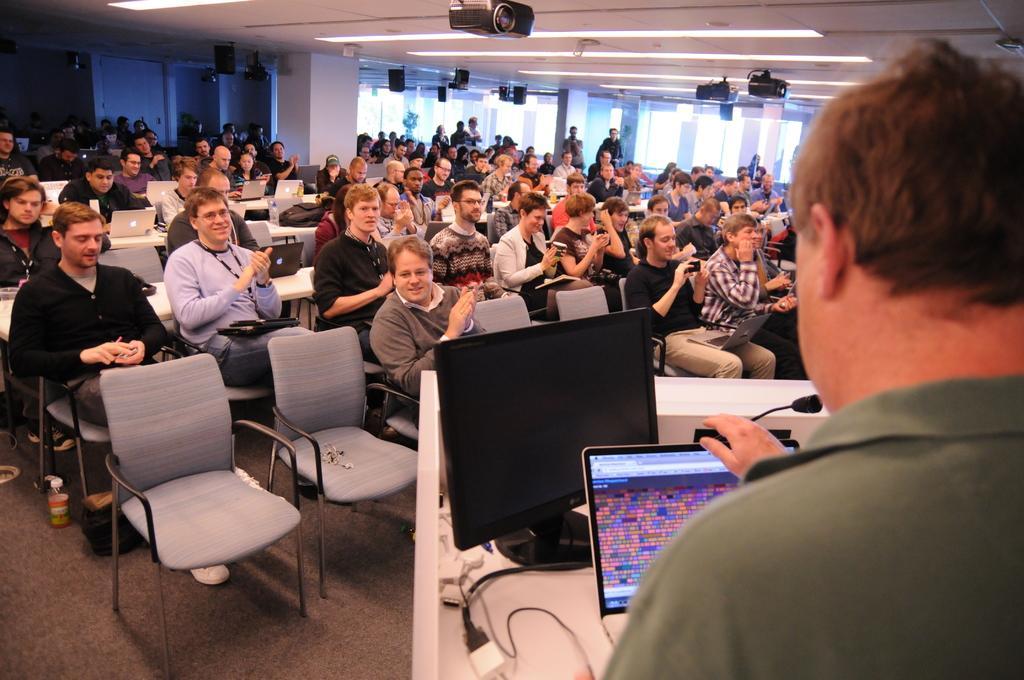Please provide a concise description of this image. In this image we can see a group of people sitting on the chairs and the tables containing the laptops and bags on them. We can also see a bottle on the floor, a group of people standing, some pillars, speaker boxes, windows, cameras and a roof with some ceiling lights. In the foreground we can see a man standing beside a speaker stand containing the monitors, wires and a mic with a stand on it. 